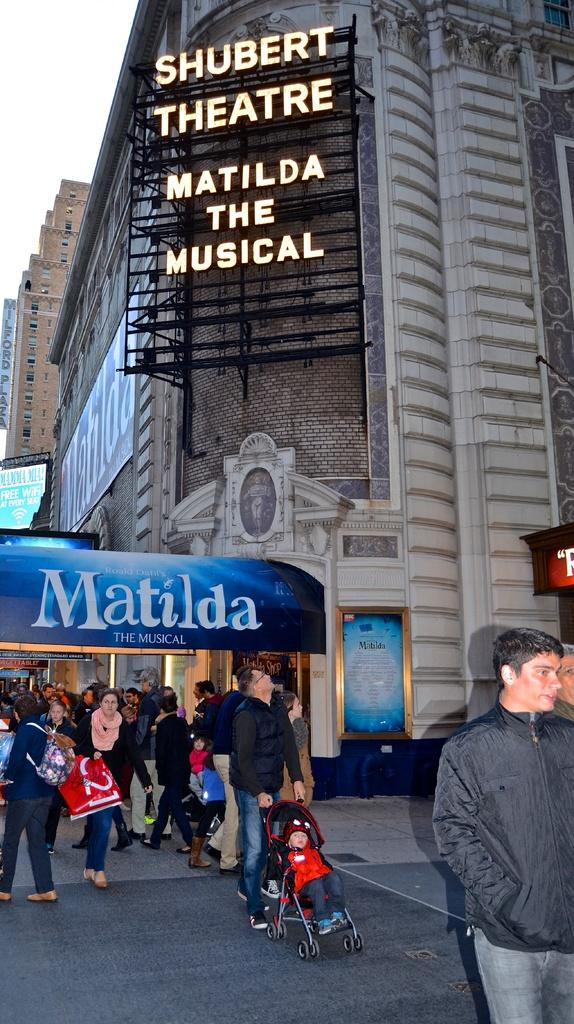What can be seen in the image involving a group of people? There is a group of people in the image. What type of structures are present in the image? There are buildings in the image. What kind of advertisements are visible in the image? There are hoardings in the image. What is the baby in the image using for transportation? There is a baby in a baby stroller in the image. What type of trousers is the baby wearing in the image? There is no information about the baby's clothing in the image, so we cannot determine if they are wearing trousers or any other type of garment. Can you tell me how many lamps are visible in the image? There is no mention of lamps in the provided facts, so we cannot determine if any lamps are present in the image. 